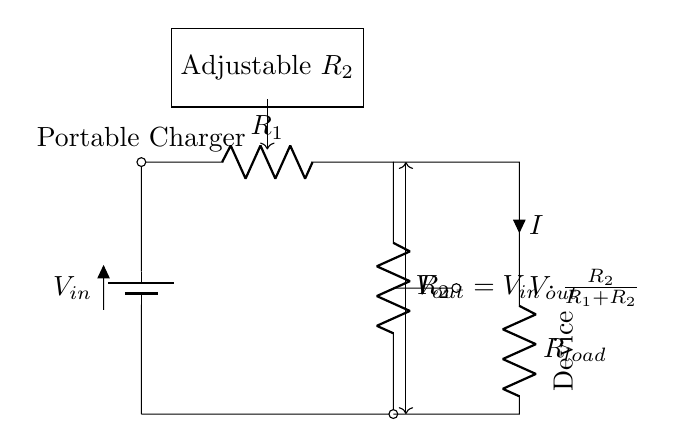What components are in the circuit? The circuit contains a battery, two resistors (R1 and R2), and a load resistor (Rload).
Answer: Battery, R1, R2, Rload What is the function of R2 in this circuit? R2 is the adjustable resistor that determines the output voltage based on the voltage divider formula.
Answer: Adjustable resistor What does the equation for Vout represent? The equation for Vout shows how the output voltage is calculated based on the input voltage and the values of R1 and R2 using the voltage divider principle.
Answer: Voltage divider principle If R1 is 100 ohms and R2 is 200 ohms, what is Vout when Vin is 9 volts? Using the voltage divider formula, Vout = Vin * (R2 / (R1 + R2)), we substitute the values: Vout = 9 * (200 / (100 + 200)) = 6 volts.
Answer: 6 volts What does an increase in R2 do to Vout? Increasing R2 increases Vout because Vout is proportional to the ratio of R2 to the total resistance (R1 + R2) in the voltage divider formula.
Answer: Increases Vout What is the role of the load resistor Rload? Rload represents the device that is being powered by the output voltage from the voltage divider, reflecting the load's effect on the circuit.
Answer: Device load 